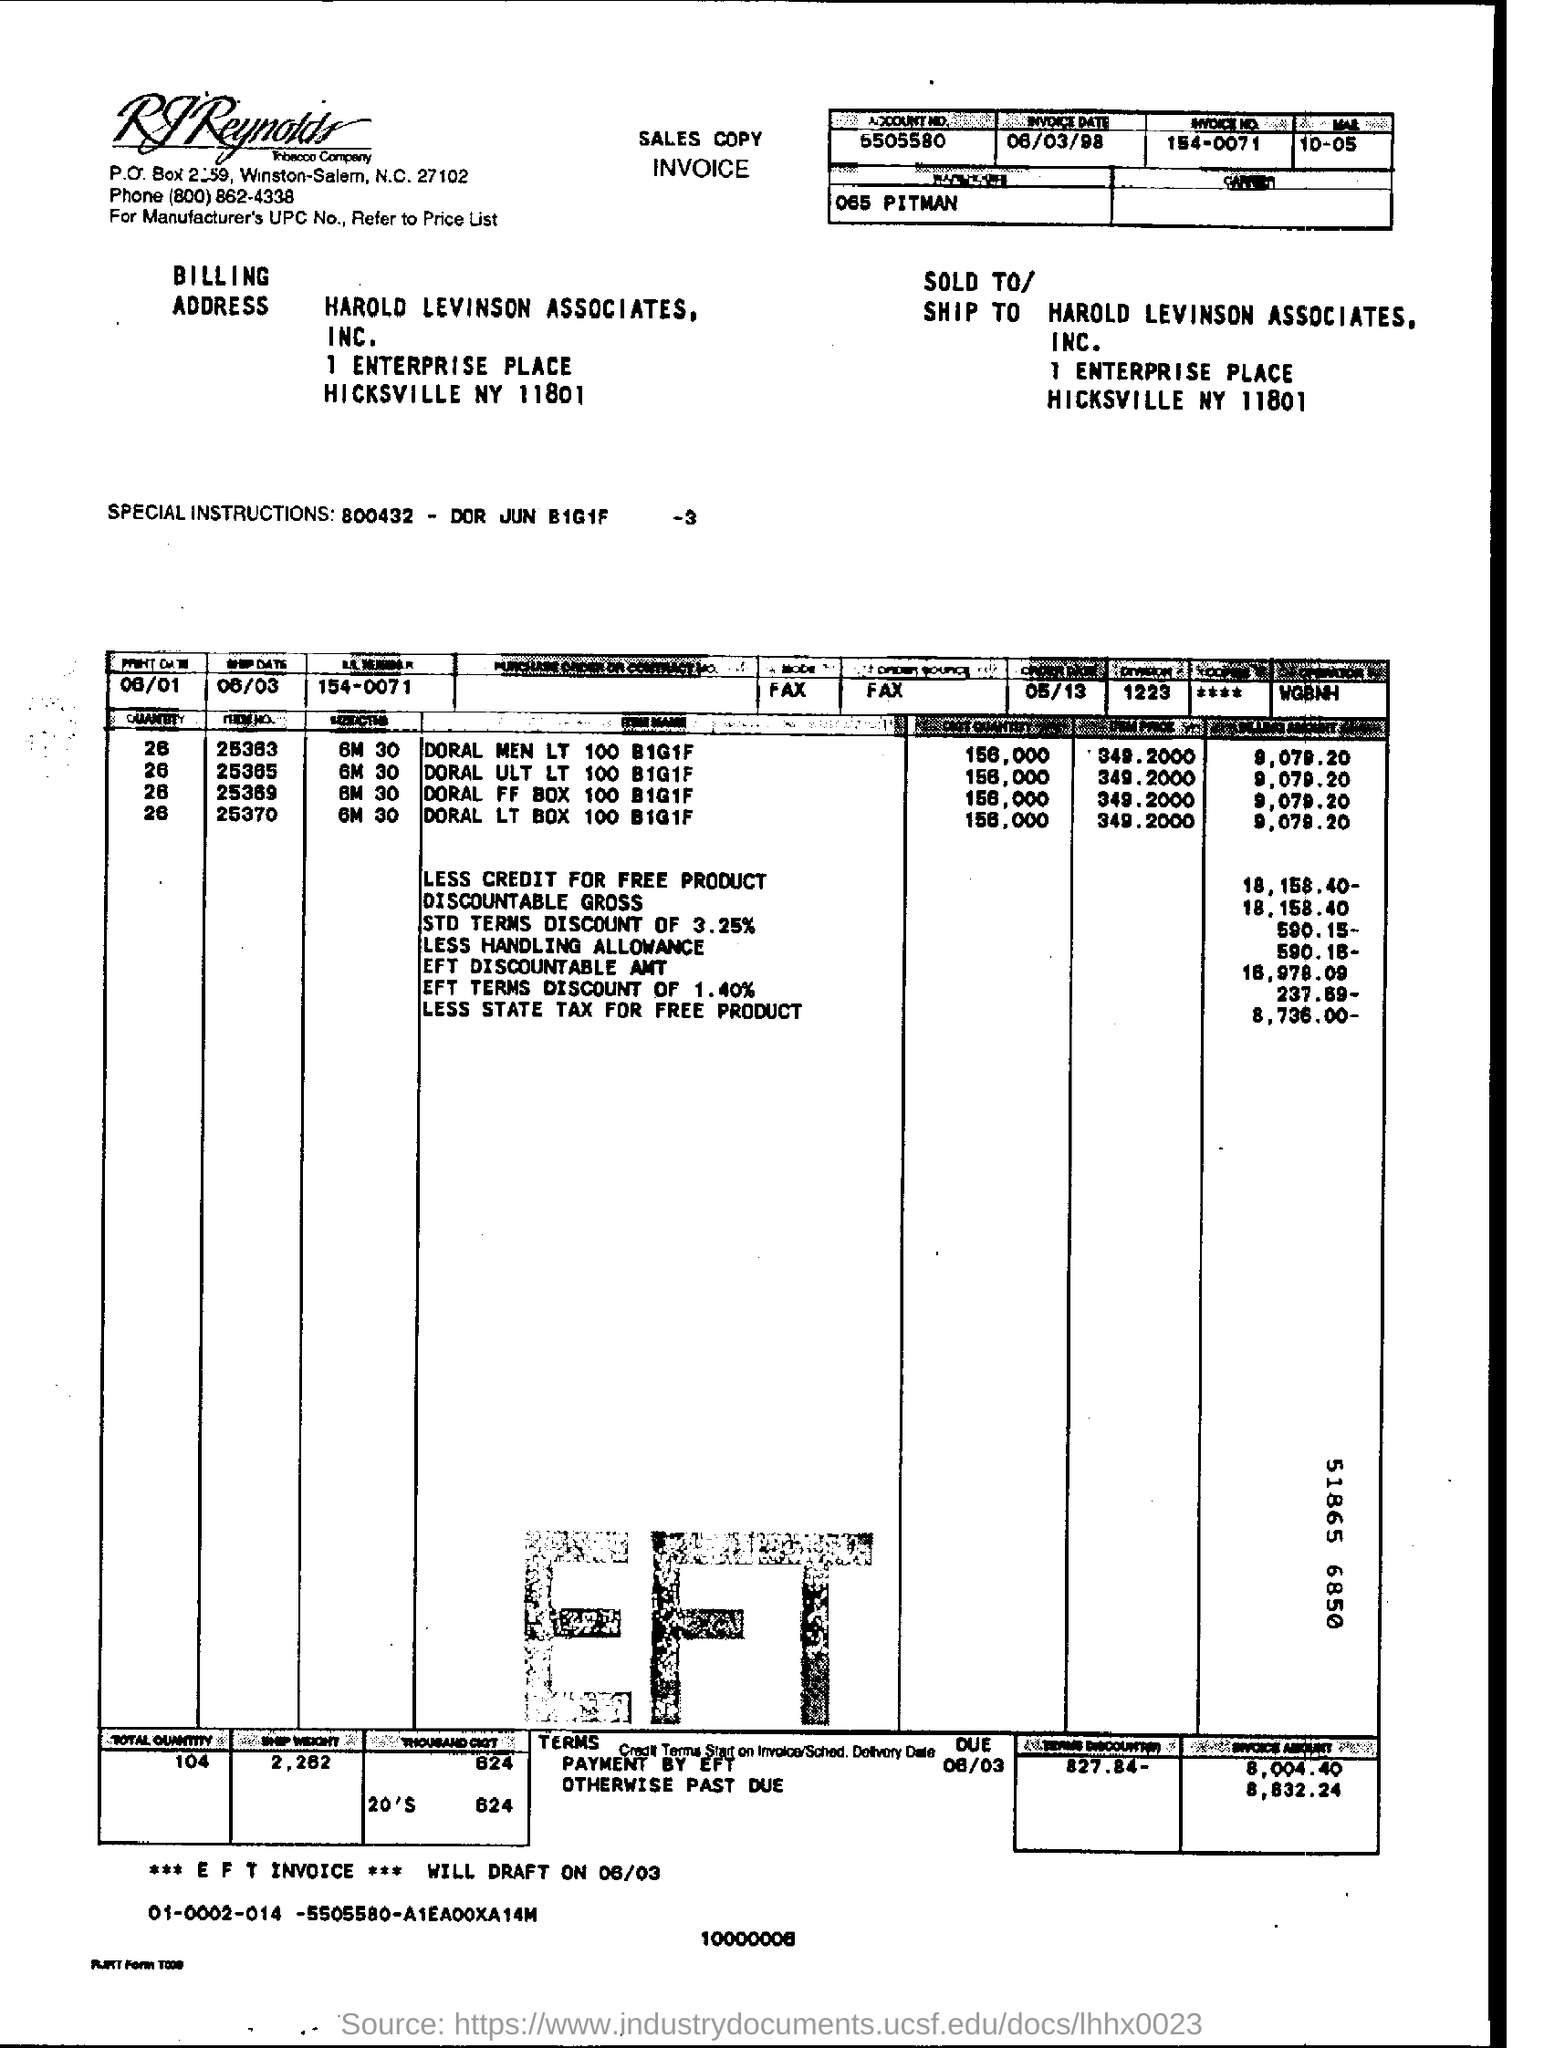Outline some significant characteristics in this image. The invoice date is June 3, 1998. The EFT invoice will be drafted on March 6, 2023. To whom this letter of intent is sold, HAROLD LEVINSON ASSOCIATES, INC. hereby offers our services. The total quantity is 104. 